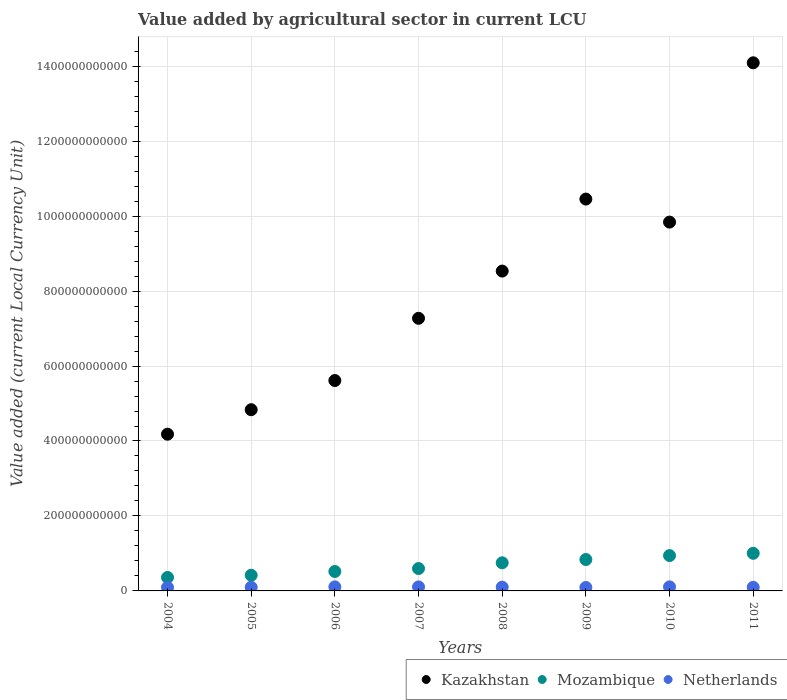How many different coloured dotlines are there?
Offer a terse response. 3. What is the value added by agricultural sector in Kazakhstan in 2006?
Offer a very short reply. 5.61e+11. Across all years, what is the maximum value added by agricultural sector in Mozambique?
Make the answer very short. 1.00e+11. Across all years, what is the minimum value added by agricultural sector in Kazakhstan?
Make the answer very short. 4.18e+11. What is the total value added by agricultural sector in Kazakhstan in the graph?
Offer a very short reply. 6.48e+12. What is the difference between the value added by agricultural sector in Mozambique in 2008 and that in 2011?
Offer a very short reply. -2.54e+1. What is the difference between the value added by agricultural sector in Kazakhstan in 2004 and the value added by agricultural sector in Netherlands in 2009?
Offer a very short reply. 4.09e+11. What is the average value added by agricultural sector in Netherlands per year?
Give a very brief answer. 1.01e+1. In the year 2010, what is the difference between the value added by agricultural sector in Mozambique and value added by agricultural sector in Netherlands?
Keep it short and to the point. 8.35e+1. In how many years, is the value added by agricultural sector in Netherlands greater than 280000000000 LCU?
Ensure brevity in your answer.  0. What is the ratio of the value added by agricultural sector in Netherlands in 2004 to that in 2009?
Make the answer very short. 1.03. Is the difference between the value added by agricultural sector in Mozambique in 2004 and 2011 greater than the difference between the value added by agricultural sector in Netherlands in 2004 and 2011?
Provide a succinct answer. No. What is the difference between the highest and the second highest value added by agricultural sector in Kazakhstan?
Your answer should be very brief. 3.64e+11. What is the difference between the highest and the lowest value added by agricultural sector in Netherlands?
Provide a succinct answer. 1.71e+09. Is the sum of the value added by agricultural sector in Netherlands in 2007 and 2011 greater than the maximum value added by agricultural sector in Mozambique across all years?
Give a very brief answer. No. Is it the case that in every year, the sum of the value added by agricultural sector in Mozambique and value added by agricultural sector in Kazakhstan  is greater than the value added by agricultural sector in Netherlands?
Offer a very short reply. Yes. Does the value added by agricultural sector in Mozambique monotonically increase over the years?
Offer a very short reply. Yes. Is the value added by agricultural sector in Kazakhstan strictly greater than the value added by agricultural sector in Netherlands over the years?
Give a very brief answer. Yes. What is the difference between two consecutive major ticks on the Y-axis?
Ensure brevity in your answer.  2.00e+11. Are the values on the major ticks of Y-axis written in scientific E-notation?
Your response must be concise. No. Does the graph contain grids?
Keep it short and to the point. Yes. Where does the legend appear in the graph?
Your response must be concise. Bottom right. What is the title of the graph?
Give a very brief answer. Value added by agricultural sector in current LCU. Does "Honduras" appear as one of the legend labels in the graph?
Provide a succinct answer. No. What is the label or title of the X-axis?
Make the answer very short. Years. What is the label or title of the Y-axis?
Offer a terse response. Value added (current Local Currency Unit). What is the Value added (current Local Currency Unit) in Kazakhstan in 2004?
Offer a terse response. 4.18e+11. What is the Value added (current Local Currency Unit) of Mozambique in 2004?
Make the answer very short. 3.59e+1. What is the Value added (current Local Currency Unit) of Netherlands in 2004?
Your response must be concise. 9.42e+09. What is the Value added (current Local Currency Unit) in Kazakhstan in 2005?
Your answer should be compact. 4.83e+11. What is the Value added (current Local Currency Unit) of Mozambique in 2005?
Your response must be concise. 4.18e+1. What is the Value added (current Local Currency Unit) in Netherlands in 2005?
Your answer should be compact. 9.77e+09. What is the Value added (current Local Currency Unit) of Kazakhstan in 2006?
Your response must be concise. 5.61e+11. What is the Value added (current Local Currency Unit) in Mozambique in 2006?
Keep it short and to the point. 5.19e+1. What is the Value added (current Local Currency Unit) in Netherlands in 2006?
Offer a very short reply. 1.09e+1. What is the Value added (current Local Currency Unit) in Kazakhstan in 2007?
Your answer should be very brief. 7.27e+11. What is the Value added (current Local Currency Unit) of Mozambique in 2007?
Offer a terse response. 5.97e+1. What is the Value added (current Local Currency Unit) of Netherlands in 2007?
Offer a very short reply. 1.08e+1. What is the Value added (current Local Currency Unit) in Kazakhstan in 2008?
Keep it short and to the point. 8.53e+11. What is the Value added (current Local Currency Unit) in Mozambique in 2008?
Provide a succinct answer. 7.50e+1. What is the Value added (current Local Currency Unit) in Netherlands in 2008?
Your answer should be very brief. 1.01e+1. What is the Value added (current Local Currency Unit) in Kazakhstan in 2009?
Offer a terse response. 1.05e+12. What is the Value added (current Local Currency Unit) of Mozambique in 2009?
Your answer should be very brief. 8.38e+1. What is the Value added (current Local Currency Unit) of Netherlands in 2009?
Keep it short and to the point. 9.19e+09. What is the Value added (current Local Currency Unit) of Kazakhstan in 2010?
Make the answer very short. 9.84e+11. What is the Value added (current Local Currency Unit) of Mozambique in 2010?
Your answer should be compact. 9.43e+1. What is the Value added (current Local Currency Unit) of Netherlands in 2010?
Make the answer very short. 1.08e+1. What is the Value added (current Local Currency Unit) in Kazakhstan in 2011?
Provide a short and direct response. 1.41e+12. What is the Value added (current Local Currency Unit) of Mozambique in 2011?
Ensure brevity in your answer.  1.00e+11. What is the Value added (current Local Currency Unit) of Netherlands in 2011?
Your response must be concise. 9.70e+09. Across all years, what is the maximum Value added (current Local Currency Unit) in Kazakhstan?
Make the answer very short. 1.41e+12. Across all years, what is the maximum Value added (current Local Currency Unit) in Mozambique?
Your answer should be compact. 1.00e+11. Across all years, what is the maximum Value added (current Local Currency Unit) in Netherlands?
Provide a succinct answer. 1.09e+1. Across all years, what is the minimum Value added (current Local Currency Unit) in Kazakhstan?
Your answer should be very brief. 4.18e+11. Across all years, what is the minimum Value added (current Local Currency Unit) in Mozambique?
Provide a succinct answer. 3.59e+1. Across all years, what is the minimum Value added (current Local Currency Unit) of Netherlands?
Ensure brevity in your answer.  9.19e+09. What is the total Value added (current Local Currency Unit) in Kazakhstan in the graph?
Keep it short and to the point. 6.48e+12. What is the total Value added (current Local Currency Unit) of Mozambique in the graph?
Provide a succinct answer. 5.43e+11. What is the total Value added (current Local Currency Unit) in Netherlands in the graph?
Your response must be concise. 8.07e+1. What is the difference between the Value added (current Local Currency Unit) of Kazakhstan in 2004 and that in 2005?
Your answer should be compact. -6.54e+1. What is the difference between the Value added (current Local Currency Unit) in Mozambique in 2004 and that in 2005?
Make the answer very short. -5.84e+09. What is the difference between the Value added (current Local Currency Unit) of Netherlands in 2004 and that in 2005?
Ensure brevity in your answer.  -3.41e+08. What is the difference between the Value added (current Local Currency Unit) of Kazakhstan in 2004 and that in 2006?
Offer a terse response. -1.43e+11. What is the difference between the Value added (current Local Currency Unit) in Mozambique in 2004 and that in 2006?
Ensure brevity in your answer.  -1.59e+1. What is the difference between the Value added (current Local Currency Unit) of Netherlands in 2004 and that in 2006?
Your response must be concise. -1.48e+09. What is the difference between the Value added (current Local Currency Unit) of Kazakhstan in 2004 and that in 2007?
Give a very brief answer. -3.09e+11. What is the difference between the Value added (current Local Currency Unit) of Mozambique in 2004 and that in 2007?
Ensure brevity in your answer.  -2.38e+1. What is the difference between the Value added (current Local Currency Unit) of Netherlands in 2004 and that in 2007?
Your answer should be very brief. -1.34e+09. What is the difference between the Value added (current Local Currency Unit) of Kazakhstan in 2004 and that in 2008?
Provide a short and direct response. -4.35e+11. What is the difference between the Value added (current Local Currency Unit) in Mozambique in 2004 and that in 2008?
Keep it short and to the point. -3.91e+1. What is the difference between the Value added (current Local Currency Unit) in Netherlands in 2004 and that in 2008?
Provide a succinct answer. -6.74e+08. What is the difference between the Value added (current Local Currency Unit) in Kazakhstan in 2004 and that in 2009?
Provide a succinct answer. -6.27e+11. What is the difference between the Value added (current Local Currency Unit) of Mozambique in 2004 and that in 2009?
Your answer should be compact. -4.78e+1. What is the difference between the Value added (current Local Currency Unit) in Netherlands in 2004 and that in 2009?
Provide a short and direct response. 2.33e+08. What is the difference between the Value added (current Local Currency Unit) of Kazakhstan in 2004 and that in 2010?
Keep it short and to the point. -5.66e+11. What is the difference between the Value added (current Local Currency Unit) of Mozambique in 2004 and that in 2010?
Keep it short and to the point. -5.84e+1. What is the difference between the Value added (current Local Currency Unit) in Netherlands in 2004 and that in 2010?
Offer a very short reply. -1.40e+09. What is the difference between the Value added (current Local Currency Unit) in Kazakhstan in 2004 and that in 2011?
Give a very brief answer. -9.91e+11. What is the difference between the Value added (current Local Currency Unit) of Mozambique in 2004 and that in 2011?
Your answer should be compact. -6.44e+1. What is the difference between the Value added (current Local Currency Unit) of Netherlands in 2004 and that in 2011?
Provide a succinct answer. -2.72e+08. What is the difference between the Value added (current Local Currency Unit) of Kazakhstan in 2005 and that in 2006?
Make the answer very short. -7.78e+1. What is the difference between the Value added (current Local Currency Unit) of Mozambique in 2005 and that in 2006?
Your answer should be very brief. -1.01e+1. What is the difference between the Value added (current Local Currency Unit) of Netherlands in 2005 and that in 2006?
Offer a terse response. -1.14e+09. What is the difference between the Value added (current Local Currency Unit) in Kazakhstan in 2005 and that in 2007?
Keep it short and to the point. -2.44e+11. What is the difference between the Value added (current Local Currency Unit) of Mozambique in 2005 and that in 2007?
Provide a short and direct response. -1.79e+1. What is the difference between the Value added (current Local Currency Unit) of Netherlands in 2005 and that in 2007?
Keep it short and to the point. -9.94e+08. What is the difference between the Value added (current Local Currency Unit) of Kazakhstan in 2005 and that in 2008?
Your response must be concise. -3.70e+11. What is the difference between the Value added (current Local Currency Unit) of Mozambique in 2005 and that in 2008?
Your answer should be very brief. -3.32e+1. What is the difference between the Value added (current Local Currency Unit) in Netherlands in 2005 and that in 2008?
Offer a terse response. -3.33e+08. What is the difference between the Value added (current Local Currency Unit) of Kazakhstan in 2005 and that in 2009?
Your response must be concise. -5.62e+11. What is the difference between the Value added (current Local Currency Unit) of Mozambique in 2005 and that in 2009?
Offer a very short reply. -4.20e+1. What is the difference between the Value added (current Local Currency Unit) in Netherlands in 2005 and that in 2009?
Give a very brief answer. 5.74e+08. What is the difference between the Value added (current Local Currency Unit) in Kazakhstan in 2005 and that in 2010?
Your answer should be compact. -5.01e+11. What is the difference between the Value added (current Local Currency Unit) in Mozambique in 2005 and that in 2010?
Your answer should be compact. -5.25e+1. What is the difference between the Value added (current Local Currency Unit) in Netherlands in 2005 and that in 2010?
Offer a very short reply. -1.06e+09. What is the difference between the Value added (current Local Currency Unit) of Kazakhstan in 2005 and that in 2011?
Offer a very short reply. -9.26e+11. What is the difference between the Value added (current Local Currency Unit) of Mozambique in 2005 and that in 2011?
Provide a succinct answer. -5.86e+1. What is the difference between the Value added (current Local Currency Unit) of Netherlands in 2005 and that in 2011?
Offer a very short reply. 6.90e+07. What is the difference between the Value added (current Local Currency Unit) in Kazakhstan in 2006 and that in 2007?
Your response must be concise. -1.66e+11. What is the difference between the Value added (current Local Currency Unit) of Mozambique in 2006 and that in 2007?
Your answer should be compact. -7.85e+09. What is the difference between the Value added (current Local Currency Unit) of Netherlands in 2006 and that in 2007?
Provide a succinct answer. 1.42e+08. What is the difference between the Value added (current Local Currency Unit) in Kazakhstan in 2006 and that in 2008?
Your answer should be compact. -2.92e+11. What is the difference between the Value added (current Local Currency Unit) in Mozambique in 2006 and that in 2008?
Your response must be concise. -2.32e+1. What is the difference between the Value added (current Local Currency Unit) in Netherlands in 2006 and that in 2008?
Your answer should be compact. 8.03e+08. What is the difference between the Value added (current Local Currency Unit) of Kazakhstan in 2006 and that in 2009?
Offer a very short reply. -4.84e+11. What is the difference between the Value added (current Local Currency Unit) in Mozambique in 2006 and that in 2009?
Offer a terse response. -3.19e+1. What is the difference between the Value added (current Local Currency Unit) in Netherlands in 2006 and that in 2009?
Your answer should be very brief. 1.71e+09. What is the difference between the Value added (current Local Currency Unit) of Kazakhstan in 2006 and that in 2010?
Your answer should be compact. -4.23e+11. What is the difference between the Value added (current Local Currency Unit) of Mozambique in 2006 and that in 2010?
Provide a succinct answer. -4.24e+1. What is the difference between the Value added (current Local Currency Unit) in Netherlands in 2006 and that in 2010?
Ensure brevity in your answer.  7.40e+07. What is the difference between the Value added (current Local Currency Unit) of Kazakhstan in 2006 and that in 2011?
Your answer should be compact. -8.48e+11. What is the difference between the Value added (current Local Currency Unit) in Mozambique in 2006 and that in 2011?
Keep it short and to the point. -4.85e+1. What is the difference between the Value added (current Local Currency Unit) of Netherlands in 2006 and that in 2011?
Your answer should be compact. 1.20e+09. What is the difference between the Value added (current Local Currency Unit) in Kazakhstan in 2007 and that in 2008?
Offer a very short reply. -1.26e+11. What is the difference between the Value added (current Local Currency Unit) of Mozambique in 2007 and that in 2008?
Ensure brevity in your answer.  -1.53e+1. What is the difference between the Value added (current Local Currency Unit) in Netherlands in 2007 and that in 2008?
Your answer should be very brief. 6.61e+08. What is the difference between the Value added (current Local Currency Unit) in Kazakhstan in 2007 and that in 2009?
Your answer should be very brief. -3.18e+11. What is the difference between the Value added (current Local Currency Unit) of Mozambique in 2007 and that in 2009?
Ensure brevity in your answer.  -2.41e+1. What is the difference between the Value added (current Local Currency Unit) of Netherlands in 2007 and that in 2009?
Offer a terse response. 1.57e+09. What is the difference between the Value added (current Local Currency Unit) of Kazakhstan in 2007 and that in 2010?
Give a very brief answer. -2.57e+11. What is the difference between the Value added (current Local Currency Unit) in Mozambique in 2007 and that in 2010?
Your answer should be compact. -3.46e+1. What is the difference between the Value added (current Local Currency Unit) of Netherlands in 2007 and that in 2010?
Your response must be concise. -6.80e+07. What is the difference between the Value added (current Local Currency Unit) of Kazakhstan in 2007 and that in 2011?
Provide a succinct answer. -6.82e+11. What is the difference between the Value added (current Local Currency Unit) in Mozambique in 2007 and that in 2011?
Give a very brief answer. -4.07e+1. What is the difference between the Value added (current Local Currency Unit) of Netherlands in 2007 and that in 2011?
Make the answer very short. 1.06e+09. What is the difference between the Value added (current Local Currency Unit) of Kazakhstan in 2008 and that in 2009?
Offer a very short reply. -1.92e+11. What is the difference between the Value added (current Local Currency Unit) in Mozambique in 2008 and that in 2009?
Your answer should be very brief. -8.76e+09. What is the difference between the Value added (current Local Currency Unit) in Netherlands in 2008 and that in 2009?
Make the answer very short. 9.07e+08. What is the difference between the Value added (current Local Currency Unit) of Kazakhstan in 2008 and that in 2010?
Your answer should be compact. -1.31e+11. What is the difference between the Value added (current Local Currency Unit) in Mozambique in 2008 and that in 2010?
Offer a terse response. -1.93e+1. What is the difference between the Value added (current Local Currency Unit) of Netherlands in 2008 and that in 2010?
Provide a short and direct response. -7.29e+08. What is the difference between the Value added (current Local Currency Unit) of Kazakhstan in 2008 and that in 2011?
Your answer should be very brief. -5.56e+11. What is the difference between the Value added (current Local Currency Unit) in Mozambique in 2008 and that in 2011?
Ensure brevity in your answer.  -2.54e+1. What is the difference between the Value added (current Local Currency Unit) in Netherlands in 2008 and that in 2011?
Provide a short and direct response. 4.02e+08. What is the difference between the Value added (current Local Currency Unit) of Kazakhstan in 2009 and that in 2010?
Provide a short and direct response. 6.14e+1. What is the difference between the Value added (current Local Currency Unit) of Mozambique in 2009 and that in 2010?
Keep it short and to the point. -1.05e+1. What is the difference between the Value added (current Local Currency Unit) of Netherlands in 2009 and that in 2010?
Provide a short and direct response. -1.64e+09. What is the difference between the Value added (current Local Currency Unit) of Kazakhstan in 2009 and that in 2011?
Ensure brevity in your answer.  -3.64e+11. What is the difference between the Value added (current Local Currency Unit) in Mozambique in 2009 and that in 2011?
Provide a short and direct response. -1.66e+1. What is the difference between the Value added (current Local Currency Unit) in Netherlands in 2009 and that in 2011?
Your response must be concise. -5.05e+08. What is the difference between the Value added (current Local Currency Unit) of Kazakhstan in 2010 and that in 2011?
Make the answer very short. -4.25e+11. What is the difference between the Value added (current Local Currency Unit) of Mozambique in 2010 and that in 2011?
Ensure brevity in your answer.  -6.08e+09. What is the difference between the Value added (current Local Currency Unit) of Netherlands in 2010 and that in 2011?
Make the answer very short. 1.13e+09. What is the difference between the Value added (current Local Currency Unit) in Kazakhstan in 2004 and the Value added (current Local Currency Unit) in Mozambique in 2005?
Your answer should be very brief. 3.76e+11. What is the difference between the Value added (current Local Currency Unit) of Kazakhstan in 2004 and the Value added (current Local Currency Unit) of Netherlands in 2005?
Make the answer very short. 4.08e+11. What is the difference between the Value added (current Local Currency Unit) in Mozambique in 2004 and the Value added (current Local Currency Unit) in Netherlands in 2005?
Ensure brevity in your answer.  2.62e+1. What is the difference between the Value added (current Local Currency Unit) of Kazakhstan in 2004 and the Value added (current Local Currency Unit) of Mozambique in 2006?
Your answer should be compact. 3.66e+11. What is the difference between the Value added (current Local Currency Unit) in Kazakhstan in 2004 and the Value added (current Local Currency Unit) in Netherlands in 2006?
Your answer should be compact. 4.07e+11. What is the difference between the Value added (current Local Currency Unit) in Mozambique in 2004 and the Value added (current Local Currency Unit) in Netherlands in 2006?
Offer a terse response. 2.50e+1. What is the difference between the Value added (current Local Currency Unit) of Kazakhstan in 2004 and the Value added (current Local Currency Unit) of Mozambique in 2007?
Give a very brief answer. 3.58e+11. What is the difference between the Value added (current Local Currency Unit) in Kazakhstan in 2004 and the Value added (current Local Currency Unit) in Netherlands in 2007?
Keep it short and to the point. 4.07e+11. What is the difference between the Value added (current Local Currency Unit) of Mozambique in 2004 and the Value added (current Local Currency Unit) of Netherlands in 2007?
Offer a very short reply. 2.52e+1. What is the difference between the Value added (current Local Currency Unit) of Kazakhstan in 2004 and the Value added (current Local Currency Unit) of Mozambique in 2008?
Your answer should be very brief. 3.43e+11. What is the difference between the Value added (current Local Currency Unit) in Kazakhstan in 2004 and the Value added (current Local Currency Unit) in Netherlands in 2008?
Offer a very short reply. 4.08e+11. What is the difference between the Value added (current Local Currency Unit) of Mozambique in 2004 and the Value added (current Local Currency Unit) of Netherlands in 2008?
Offer a very short reply. 2.58e+1. What is the difference between the Value added (current Local Currency Unit) in Kazakhstan in 2004 and the Value added (current Local Currency Unit) in Mozambique in 2009?
Give a very brief answer. 3.34e+11. What is the difference between the Value added (current Local Currency Unit) in Kazakhstan in 2004 and the Value added (current Local Currency Unit) in Netherlands in 2009?
Offer a terse response. 4.09e+11. What is the difference between the Value added (current Local Currency Unit) in Mozambique in 2004 and the Value added (current Local Currency Unit) in Netherlands in 2009?
Ensure brevity in your answer.  2.67e+1. What is the difference between the Value added (current Local Currency Unit) of Kazakhstan in 2004 and the Value added (current Local Currency Unit) of Mozambique in 2010?
Provide a succinct answer. 3.24e+11. What is the difference between the Value added (current Local Currency Unit) of Kazakhstan in 2004 and the Value added (current Local Currency Unit) of Netherlands in 2010?
Provide a short and direct response. 4.07e+11. What is the difference between the Value added (current Local Currency Unit) of Mozambique in 2004 and the Value added (current Local Currency Unit) of Netherlands in 2010?
Offer a very short reply. 2.51e+1. What is the difference between the Value added (current Local Currency Unit) in Kazakhstan in 2004 and the Value added (current Local Currency Unit) in Mozambique in 2011?
Your answer should be very brief. 3.18e+11. What is the difference between the Value added (current Local Currency Unit) in Kazakhstan in 2004 and the Value added (current Local Currency Unit) in Netherlands in 2011?
Offer a terse response. 4.08e+11. What is the difference between the Value added (current Local Currency Unit) in Mozambique in 2004 and the Value added (current Local Currency Unit) in Netherlands in 2011?
Your answer should be compact. 2.62e+1. What is the difference between the Value added (current Local Currency Unit) in Kazakhstan in 2005 and the Value added (current Local Currency Unit) in Mozambique in 2006?
Your response must be concise. 4.32e+11. What is the difference between the Value added (current Local Currency Unit) of Kazakhstan in 2005 and the Value added (current Local Currency Unit) of Netherlands in 2006?
Provide a succinct answer. 4.73e+11. What is the difference between the Value added (current Local Currency Unit) of Mozambique in 2005 and the Value added (current Local Currency Unit) of Netherlands in 2006?
Ensure brevity in your answer.  3.09e+1. What is the difference between the Value added (current Local Currency Unit) in Kazakhstan in 2005 and the Value added (current Local Currency Unit) in Mozambique in 2007?
Give a very brief answer. 4.24e+11. What is the difference between the Value added (current Local Currency Unit) of Kazakhstan in 2005 and the Value added (current Local Currency Unit) of Netherlands in 2007?
Your response must be concise. 4.73e+11. What is the difference between the Value added (current Local Currency Unit) in Mozambique in 2005 and the Value added (current Local Currency Unit) in Netherlands in 2007?
Keep it short and to the point. 3.10e+1. What is the difference between the Value added (current Local Currency Unit) of Kazakhstan in 2005 and the Value added (current Local Currency Unit) of Mozambique in 2008?
Keep it short and to the point. 4.08e+11. What is the difference between the Value added (current Local Currency Unit) of Kazakhstan in 2005 and the Value added (current Local Currency Unit) of Netherlands in 2008?
Ensure brevity in your answer.  4.73e+11. What is the difference between the Value added (current Local Currency Unit) of Mozambique in 2005 and the Value added (current Local Currency Unit) of Netherlands in 2008?
Your answer should be compact. 3.17e+1. What is the difference between the Value added (current Local Currency Unit) of Kazakhstan in 2005 and the Value added (current Local Currency Unit) of Mozambique in 2009?
Provide a succinct answer. 4.00e+11. What is the difference between the Value added (current Local Currency Unit) in Kazakhstan in 2005 and the Value added (current Local Currency Unit) in Netherlands in 2009?
Keep it short and to the point. 4.74e+11. What is the difference between the Value added (current Local Currency Unit) in Mozambique in 2005 and the Value added (current Local Currency Unit) in Netherlands in 2009?
Offer a very short reply. 3.26e+1. What is the difference between the Value added (current Local Currency Unit) in Kazakhstan in 2005 and the Value added (current Local Currency Unit) in Mozambique in 2010?
Give a very brief answer. 3.89e+11. What is the difference between the Value added (current Local Currency Unit) in Kazakhstan in 2005 and the Value added (current Local Currency Unit) in Netherlands in 2010?
Offer a terse response. 4.73e+11. What is the difference between the Value added (current Local Currency Unit) in Mozambique in 2005 and the Value added (current Local Currency Unit) in Netherlands in 2010?
Give a very brief answer. 3.10e+1. What is the difference between the Value added (current Local Currency Unit) in Kazakhstan in 2005 and the Value added (current Local Currency Unit) in Mozambique in 2011?
Offer a terse response. 3.83e+11. What is the difference between the Value added (current Local Currency Unit) of Kazakhstan in 2005 and the Value added (current Local Currency Unit) of Netherlands in 2011?
Keep it short and to the point. 4.74e+11. What is the difference between the Value added (current Local Currency Unit) of Mozambique in 2005 and the Value added (current Local Currency Unit) of Netherlands in 2011?
Provide a short and direct response. 3.21e+1. What is the difference between the Value added (current Local Currency Unit) of Kazakhstan in 2006 and the Value added (current Local Currency Unit) of Mozambique in 2007?
Give a very brief answer. 5.02e+11. What is the difference between the Value added (current Local Currency Unit) in Kazakhstan in 2006 and the Value added (current Local Currency Unit) in Netherlands in 2007?
Provide a succinct answer. 5.51e+11. What is the difference between the Value added (current Local Currency Unit) in Mozambique in 2006 and the Value added (current Local Currency Unit) in Netherlands in 2007?
Your answer should be compact. 4.11e+1. What is the difference between the Value added (current Local Currency Unit) of Kazakhstan in 2006 and the Value added (current Local Currency Unit) of Mozambique in 2008?
Your response must be concise. 4.86e+11. What is the difference between the Value added (current Local Currency Unit) in Kazakhstan in 2006 and the Value added (current Local Currency Unit) in Netherlands in 2008?
Offer a terse response. 5.51e+11. What is the difference between the Value added (current Local Currency Unit) of Mozambique in 2006 and the Value added (current Local Currency Unit) of Netherlands in 2008?
Your answer should be compact. 4.18e+1. What is the difference between the Value added (current Local Currency Unit) in Kazakhstan in 2006 and the Value added (current Local Currency Unit) in Mozambique in 2009?
Keep it short and to the point. 4.78e+11. What is the difference between the Value added (current Local Currency Unit) in Kazakhstan in 2006 and the Value added (current Local Currency Unit) in Netherlands in 2009?
Your answer should be very brief. 5.52e+11. What is the difference between the Value added (current Local Currency Unit) in Mozambique in 2006 and the Value added (current Local Currency Unit) in Netherlands in 2009?
Provide a succinct answer. 4.27e+1. What is the difference between the Value added (current Local Currency Unit) in Kazakhstan in 2006 and the Value added (current Local Currency Unit) in Mozambique in 2010?
Give a very brief answer. 4.67e+11. What is the difference between the Value added (current Local Currency Unit) in Kazakhstan in 2006 and the Value added (current Local Currency Unit) in Netherlands in 2010?
Provide a succinct answer. 5.51e+11. What is the difference between the Value added (current Local Currency Unit) of Mozambique in 2006 and the Value added (current Local Currency Unit) of Netherlands in 2010?
Make the answer very short. 4.10e+1. What is the difference between the Value added (current Local Currency Unit) of Kazakhstan in 2006 and the Value added (current Local Currency Unit) of Mozambique in 2011?
Offer a very short reply. 4.61e+11. What is the difference between the Value added (current Local Currency Unit) of Kazakhstan in 2006 and the Value added (current Local Currency Unit) of Netherlands in 2011?
Your answer should be compact. 5.52e+11. What is the difference between the Value added (current Local Currency Unit) in Mozambique in 2006 and the Value added (current Local Currency Unit) in Netherlands in 2011?
Give a very brief answer. 4.22e+1. What is the difference between the Value added (current Local Currency Unit) of Kazakhstan in 2007 and the Value added (current Local Currency Unit) of Mozambique in 2008?
Give a very brief answer. 6.52e+11. What is the difference between the Value added (current Local Currency Unit) of Kazakhstan in 2007 and the Value added (current Local Currency Unit) of Netherlands in 2008?
Make the answer very short. 7.17e+11. What is the difference between the Value added (current Local Currency Unit) of Mozambique in 2007 and the Value added (current Local Currency Unit) of Netherlands in 2008?
Your response must be concise. 4.96e+1. What is the difference between the Value added (current Local Currency Unit) of Kazakhstan in 2007 and the Value added (current Local Currency Unit) of Mozambique in 2009?
Keep it short and to the point. 6.44e+11. What is the difference between the Value added (current Local Currency Unit) of Kazakhstan in 2007 and the Value added (current Local Currency Unit) of Netherlands in 2009?
Give a very brief answer. 7.18e+11. What is the difference between the Value added (current Local Currency Unit) of Mozambique in 2007 and the Value added (current Local Currency Unit) of Netherlands in 2009?
Ensure brevity in your answer.  5.05e+1. What is the difference between the Value added (current Local Currency Unit) of Kazakhstan in 2007 and the Value added (current Local Currency Unit) of Mozambique in 2010?
Make the answer very short. 6.33e+11. What is the difference between the Value added (current Local Currency Unit) in Kazakhstan in 2007 and the Value added (current Local Currency Unit) in Netherlands in 2010?
Your answer should be compact. 7.17e+11. What is the difference between the Value added (current Local Currency Unit) of Mozambique in 2007 and the Value added (current Local Currency Unit) of Netherlands in 2010?
Offer a very short reply. 4.89e+1. What is the difference between the Value added (current Local Currency Unit) of Kazakhstan in 2007 and the Value added (current Local Currency Unit) of Mozambique in 2011?
Offer a very short reply. 6.27e+11. What is the difference between the Value added (current Local Currency Unit) of Kazakhstan in 2007 and the Value added (current Local Currency Unit) of Netherlands in 2011?
Your answer should be very brief. 7.18e+11. What is the difference between the Value added (current Local Currency Unit) of Mozambique in 2007 and the Value added (current Local Currency Unit) of Netherlands in 2011?
Your answer should be compact. 5.00e+1. What is the difference between the Value added (current Local Currency Unit) of Kazakhstan in 2008 and the Value added (current Local Currency Unit) of Mozambique in 2009?
Your answer should be compact. 7.70e+11. What is the difference between the Value added (current Local Currency Unit) in Kazakhstan in 2008 and the Value added (current Local Currency Unit) in Netherlands in 2009?
Your answer should be compact. 8.44e+11. What is the difference between the Value added (current Local Currency Unit) in Mozambique in 2008 and the Value added (current Local Currency Unit) in Netherlands in 2009?
Make the answer very short. 6.58e+1. What is the difference between the Value added (current Local Currency Unit) of Kazakhstan in 2008 and the Value added (current Local Currency Unit) of Mozambique in 2010?
Ensure brevity in your answer.  7.59e+11. What is the difference between the Value added (current Local Currency Unit) of Kazakhstan in 2008 and the Value added (current Local Currency Unit) of Netherlands in 2010?
Your answer should be compact. 8.43e+11. What is the difference between the Value added (current Local Currency Unit) in Mozambique in 2008 and the Value added (current Local Currency Unit) in Netherlands in 2010?
Your response must be concise. 6.42e+1. What is the difference between the Value added (current Local Currency Unit) of Kazakhstan in 2008 and the Value added (current Local Currency Unit) of Mozambique in 2011?
Provide a short and direct response. 7.53e+11. What is the difference between the Value added (current Local Currency Unit) of Kazakhstan in 2008 and the Value added (current Local Currency Unit) of Netherlands in 2011?
Offer a terse response. 8.44e+11. What is the difference between the Value added (current Local Currency Unit) of Mozambique in 2008 and the Value added (current Local Currency Unit) of Netherlands in 2011?
Provide a succinct answer. 6.53e+1. What is the difference between the Value added (current Local Currency Unit) of Kazakhstan in 2009 and the Value added (current Local Currency Unit) of Mozambique in 2010?
Provide a short and direct response. 9.51e+11. What is the difference between the Value added (current Local Currency Unit) in Kazakhstan in 2009 and the Value added (current Local Currency Unit) in Netherlands in 2010?
Offer a very short reply. 1.03e+12. What is the difference between the Value added (current Local Currency Unit) of Mozambique in 2009 and the Value added (current Local Currency Unit) of Netherlands in 2010?
Ensure brevity in your answer.  7.30e+1. What is the difference between the Value added (current Local Currency Unit) in Kazakhstan in 2009 and the Value added (current Local Currency Unit) in Mozambique in 2011?
Offer a very short reply. 9.45e+11. What is the difference between the Value added (current Local Currency Unit) in Kazakhstan in 2009 and the Value added (current Local Currency Unit) in Netherlands in 2011?
Make the answer very short. 1.04e+12. What is the difference between the Value added (current Local Currency Unit) in Mozambique in 2009 and the Value added (current Local Currency Unit) in Netherlands in 2011?
Make the answer very short. 7.41e+1. What is the difference between the Value added (current Local Currency Unit) in Kazakhstan in 2010 and the Value added (current Local Currency Unit) in Mozambique in 2011?
Ensure brevity in your answer.  8.84e+11. What is the difference between the Value added (current Local Currency Unit) in Kazakhstan in 2010 and the Value added (current Local Currency Unit) in Netherlands in 2011?
Keep it short and to the point. 9.74e+11. What is the difference between the Value added (current Local Currency Unit) of Mozambique in 2010 and the Value added (current Local Currency Unit) of Netherlands in 2011?
Make the answer very short. 8.46e+1. What is the average Value added (current Local Currency Unit) in Kazakhstan per year?
Offer a terse response. 8.10e+11. What is the average Value added (current Local Currency Unit) in Mozambique per year?
Offer a terse response. 6.78e+1. What is the average Value added (current Local Currency Unit) in Netherlands per year?
Make the answer very short. 1.01e+1. In the year 2004, what is the difference between the Value added (current Local Currency Unit) in Kazakhstan and Value added (current Local Currency Unit) in Mozambique?
Your answer should be compact. 3.82e+11. In the year 2004, what is the difference between the Value added (current Local Currency Unit) in Kazakhstan and Value added (current Local Currency Unit) in Netherlands?
Your response must be concise. 4.09e+11. In the year 2004, what is the difference between the Value added (current Local Currency Unit) of Mozambique and Value added (current Local Currency Unit) of Netherlands?
Offer a very short reply. 2.65e+1. In the year 2005, what is the difference between the Value added (current Local Currency Unit) in Kazakhstan and Value added (current Local Currency Unit) in Mozambique?
Make the answer very short. 4.42e+11. In the year 2005, what is the difference between the Value added (current Local Currency Unit) of Kazakhstan and Value added (current Local Currency Unit) of Netherlands?
Offer a very short reply. 4.74e+11. In the year 2005, what is the difference between the Value added (current Local Currency Unit) in Mozambique and Value added (current Local Currency Unit) in Netherlands?
Give a very brief answer. 3.20e+1. In the year 2006, what is the difference between the Value added (current Local Currency Unit) in Kazakhstan and Value added (current Local Currency Unit) in Mozambique?
Offer a terse response. 5.09e+11. In the year 2006, what is the difference between the Value added (current Local Currency Unit) of Kazakhstan and Value added (current Local Currency Unit) of Netherlands?
Provide a succinct answer. 5.50e+11. In the year 2006, what is the difference between the Value added (current Local Currency Unit) of Mozambique and Value added (current Local Currency Unit) of Netherlands?
Offer a terse response. 4.10e+1. In the year 2007, what is the difference between the Value added (current Local Currency Unit) of Kazakhstan and Value added (current Local Currency Unit) of Mozambique?
Provide a succinct answer. 6.68e+11. In the year 2007, what is the difference between the Value added (current Local Currency Unit) in Kazakhstan and Value added (current Local Currency Unit) in Netherlands?
Offer a very short reply. 7.17e+11. In the year 2007, what is the difference between the Value added (current Local Currency Unit) of Mozambique and Value added (current Local Currency Unit) of Netherlands?
Give a very brief answer. 4.89e+1. In the year 2008, what is the difference between the Value added (current Local Currency Unit) in Kazakhstan and Value added (current Local Currency Unit) in Mozambique?
Give a very brief answer. 7.78e+11. In the year 2008, what is the difference between the Value added (current Local Currency Unit) in Kazakhstan and Value added (current Local Currency Unit) in Netherlands?
Provide a succinct answer. 8.43e+11. In the year 2008, what is the difference between the Value added (current Local Currency Unit) of Mozambique and Value added (current Local Currency Unit) of Netherlands?
Give a very brief answer. 6.49e+1. In the year 2009, what is the difference between the Value added (current Local Currency Unit) in Kazakhstan and Value added (current Local Currency Unit) in Mozambique?
Your answer should be very brief. 9.62e+11. In the year 2009, what is the difference between the Value added (current Local Currency Unit) of Kazakhstan and Value added (current Local Currency Unit) of Netherlands?
Offer a very short reply. 1.04e+12. In the year 2009, what is the difference between the Value added (current Local Currency Unit) in Mozambique and Value added (current Local Currency Unit) in Netherlands?
Your response must be concise. 7.46e+1. In the year 2010, what is the difference between the Value added (current Local Currency Unit) of Kazakhstan and Value added (current Local Currency Unit) of Mozambique?
Your answer should be very brief. 8.90e+11. In the year 2010, what is the difference between the Value added (current Local Currency Unit) in Kazakhstan and Value added (current Local Currency Unit) in Netherlands?
Keep it short and to the point. 9.73e+11. In the year 2010, what is the difference between the Value added (current Local Currency Unit) of Mozambique and Value added (current Local Currency Unit) of Netherlands?
Keep it short and to the point. 8.35e+1. In the year 2011, what is the difference between the Value added (current Local Currency Unit) in Kazakhstan and Value added (current Local Currency Unit) in Mozambique?
Ensure brevity in your answer.  1.31e+12. In the year 2011, what is the difference between the Value added (current Local Currency Unit) of Kazakhstan and Value added (current Local Currency Unit) of Netherlands?
Give a very brief answer. 1.40e+12. In the year 2011, what is the difference between the Value added (current Local Currency Unit) of Mozambique and Value added (current Local Currency Unit) of Netherlands?
Offer a very short reply. 9.07e+1. What is the ratio of the Value added (current Local Currency Unit) of Kazakhstan in 2004 to that in 2005?
Offer a terse response. 0.86. What is the ratio of the Value added (current Local Currency Unit) in Mozambique in 2004 to that in 2005?
Your response must be concise. 0.86. What is the ratio of the Value added (current Local Currency Unit) in Netherlands in 2004 to that in 2005?
Give a very brief answer. 0.97. What is the ratio of the Value added (current Local Currency Unit) of Kazakhstan in 2004 to that in 2006?
Provide a short and direct response. 0.74. What is the ratio of the Value added (current Local Currency Unit) in Mozambique in 2004 to that in 2006?
Your answer should be very brief. 0.69. What is the ratio of the Value added (current Local Currency Unit) of Netherlands in 2004 to that in 2006?
Offer a very short reply. 0.86. What is the ratio of the Value added (current Local Currency Unit) in Kazakhstan in 2004 to that in 2007?
Your answer should be very brief. 0.57. What is the ratio of the Value added (current Local Currency Unit) of Mozambique in 2004 to that in 2007?
Ensure brevity in your answer.  0.6. What is the ratio of the Value added (current Local Currency Unit) in Netherlands in 2004 to that in 2007?
Provide a succinct answer. 0.88. What is the ratio of the Value added (current Local Currency Unit) in Kazakhstan in 2004 to that in 2008?
Your answer should be very brief. 0.49. What is the ratio of the Value added (current Local Currency Unit) of Mozambique in 2004 to that in 2008?
Give a very brief answer. 0.48. What is the ratio of the Value added (current Local Currency Unit) of Netherlands in 2004 to that in 2008?
Offer a terse response. 0.93. What is the ratio of the Value added (current Local Currency Unit) of Mozambique in 2004 to that in 2009?
Give a very brief answer. 0.43. What is the ratio of the Value added (current Local Currency Unit) in Netherlands in 2004 to that in 2009?
Ensure brevity in your answer.  1.03. What is the ratio of the Value added (current Local Currency Unit) of Kazakhstan in 2004 to that in 2010?
Provide a short and direct response. 0.42. What is the ratio of the Value added (current Local Currency Unit) in Mozambique in 2004 to that in 2010?
Offer a very short reply. 0.38. What is the ratio of the Value added (current Local Currency Unit) in Netherlands in 2004 to that in 2010?
Ensure brevity in your answer.  0.87. What is the ratio of the Value added (current Local Currency Unit) of Kazakhstan in 2004 to that in 2011?
Provide a short and direct response. 0.3. What is the ratio of the Value added (current Local Currency Unit) in Mozambique in 2004 to that in 2011?
Offer a very short reply. 0.36. What is the ratio of the Value added (current Local Currency Unit) in Netherlands in 2004 to that in 2011?
Your answer should be very brief. 0.97. What is the ratio of the Value added (current Local Currency Unit) in Kazakhstan in 2005 to that in 2006?
Your answer should be compact. 0.86. What is the ratio of the Value added (current Local Currency Unit) in Mozambique in 2005 to that in 2006?
Offer a very short reply. 0.81. What is the ratio of the Value added (current Local Currency Unit) of Netherlands in 2005 to that in 2006?
Provide a succinct answer. 0.9. What is the ratio of the Value added (current Local Currency Unit) of Kazakhstan in 2005 to that in 2007?
Your answer should be compact. 0.66. What is the ratio of the Value added (current Local Currency Unit) in Mozambique in 2005 to that in 2007?
Give a very brief answer. 0.7. What is the ratio of the Value added (current Local Currency Unit) of Netherlands in 2005 to that in 2007?
Provide a succinct answer. 0.91. What is the ratio of the Value added (current Local Currency Unit) in Kazakhstan in 2005 to that in 2008?
Make the answer very short. 0.57. What is the ratio of the Value added (current Local Currency Unit) in Mozambique in 2005 to that in 2008?
Provide a short and direct response. 0.56. What is the ratio of the Value added (current Local Currency Unit) of Kazakhstan in 2005 to that in 2009?
Offer a very short reply. 0.46. What is the ratio of the Value added (current Local Currency Unit) of Mozambique in 2005 to that in 2009?
Give a very brief answer. 0.5. What is the ratio of the Value added (current Local Currency Unit) in Netherlands in 2005 to that in 2009?
Make the answer very short. 1.06. What is the ratio of the Value added (current Local Currency Unit) of Kazakhstan in 2005 to that in 2010?
Provide a succinct answer. 0.49. What is the ratio of the Value added (current Local Currency Unit) of Mozambique in 2005 to that in 2010?
Give a very brief answer. 0.44. What is the ratio of the Value added (current Local Currency Unit) of Netherlands in 2005 to that in 2010?
Your answer should be compact. 0.9. What is the ratio of the Value added (current Local Currency Unit) of Kazakhstan in 2005 to that in 2011?
Offer a very short reply. 0.34. What is the ratio of the Value added (current Local Currency Unit) of Mozambique in 2005 to that in 2011?
Provide a short and direct response. 0.42. What is the ratio of the Value added (current Local Currency Unit) of Netherlands in 2005 to that in 2011?
Make the answer very short. 1.01. What is the ratio of the Value added (current Local Currency Unit) of Kazakhstan in 2006 to that in 2007?
Provide a short and direct response. 0.77. What is the ratio of the Value added (current Local Currency Unit) of Mozambique in 2006 to that in 2007?
Give a very brief answer. 0.87. What is the ratio of the Value added (current Local Currency Unit) of Netherlands in 2006 to that in 2007?
Your answer should be compact. 1.01. What is the ratio of the Value added (current Local Currency Unit) in Kazakhstan in 2006 to that in 2008?
Give a very brief answer. 0.66. What is the ratio of the Value added (current Local Currency Unit) in Mozambique in 2006 to that in 2008?
Offer a terse response. 0.69. What is the ratio of the Value added (current Local Currency Unit) of Netherlands in 2006 to that in 2008?
Your answer should be compact. 1.08. What is the ratio of the Value added (current Local Currency Unit) in Kazakhstan in 2006 to that in 2009?
Make the answer very short. 0.54. What is the ratio of the Value added (current Local Currency Unit) in Mozambique in 2006 to that in 2009?
Offer a terse response. 0.62. What is the ratio of the Value added (current Local Currency Unit) of Netherlands in 2006 to that in 2009?
Offer a terse response. 1.19. What is the ratio of the Value added (current Local Currency Unit) of Kazakhstan in 2006 to that in 2010?
Your answer should be very brief. 0.57. What is the ratio of the Value added (current Local Currency Unit) of Mozambique in 2006 to that in 2010?
Give a very brief answer. 0.55. What is the ratio of the Value added (current Local Currency Unit) of Netherlands in 2006 to that in 2010?
Offer a terse response. 1.01. What is the ratio of the Value added (current Local Currency Unit) of Kazakhstan in 2006 to that in 2011?
Keep it short and to the point. 0.4. What is the ratio of the Value added (current Local Currency Unit) in Mozambique in 2006 to that in 2011?
Your answer should be very brief. 0.52. What is the ratio of the Value added (current Local Currency Unit) of Netherlands in 2006 to that in 2011?
Ensure brevity in your answer.  1.12. What is the ratio of the Value added (current Local Currency Unit) of Kazakhstan in 2007 to that in 2008?
Give a very brief answer. 0.85. What is the ratio of the Value added (current Local Currency Unit) of Mozambique in 2007 to that in 2008?
Ensure brevity in your answer.  0.8. What is the ratio of the Value added (current Local Currency Unit) of Netherlands in 2007 to that in 2008?
Offer a terse response. 1.07. What is the ratio of the Value added (current Local Currency Unit) of Kazakhstan in 2007 to that in 2009?
Provide a succinct answer. 0.7. What is the ratio of the Value added (current Local Currency Unit) in Mozambique in 2007 to that in 2009?
Make the answer very short. 0.71. What is the ratio of the Value added (current Local Currency Unit) of Netherlands in 2007 to that in 2009?
Provide a short and direct response. 1.17. What is the ratio of the Value added (current Local Currency Unit) of Kazakhstan in 2007 to that in 2010?
Offer a terse response. 0.74. What is the ratio of the Value added (current Local Currency Unit) of Mozambique in 2007 to that in 2010?
Your response must be concise. 0.63. What is the ratio of the Value added (current Local Currency Unit) in Netherlands in 2007 to that in 2010?
Ensure brevity in your answer.  0.99. What is the ratio of the Value added (current Local Currency Unit) of Kazakhstan in 2007 to that in 2011?
Ensure brevity in your answer.  0.52. What is the ratio of the Value added (current Local Currency Unit) in Mozambique in 2007 to that in 2011?
Your answer should be very brief. 0.59. What is the ratio of the Value added (current Local Currency Unit) in Netherlands in 2007 to that in 2011?
Keep it short and to the point. 1.11. What is the ratio of the Value added (current Local Currency Unit) in Kazakhstan in 2008 to that in 2009?
Ensure brevity in your answer.  0.82. What is the ratio of the Value added (current Local Currency Unit) in Mozambique in 2008 to that in 2009?
Your answer should be compact. 0.9. What is the ratio of the Value added (current Local Currency Unit) in Netherlands in 2008 to that in 2009?
Provide a short and direct response. 1.1. What is the ratio of the Value added (current Local Currency Unit) of Kazakhstan in 2008 to that in 2010?
Offer a terse response. 0.87. What is the ratio of the Value added (current Local Currency Unit) in Mozambique in 2008 to that in 2010?
Keep it short and to the point. 0.8. What is the ratio of the Value added (current Local Currency Unit) of Netherlands in 2008 to that in 2010?
Keep it short and to the point. 0.93. What is the ratio of the Value added (current Local Currency Unit) in Kazakhstan in 2008 to that in 2011?
Your response must be concise. 0.61. What is the ratio of the Value added (current Local Currency Unit) in Mozambique in 2008 to that in 2011?
Offer a terse response. 0.75. What is the ratio of the Value added (current Local Currency Unit) of Netherlands in 2008 to that in 2011?
Your answer should be very brief. 1.04. What is the ratio of the Value added (current Local Currency Unit) in Kazakhstan in 2009 to that in 2010?
Provide a short and direct response. 1.06. What is the ratio of the Value added (current Local Currency Unit) of Mozambique in 2009 to that in 2010?
Your answer should be compact. 0.89. What is the ratio of the Value added (current Local Currency Unit) in Netherlands in 2009 to that in 2010?
Offer a terse response. 0.85. What is the ratio of the Value added (current Local Currency Unit) in Kazakhstan in 2009 to that in 2011?
Your answer should be very brief. 0.74. What is the ratio of the Value added (current Local Currency Unit) in Mozambique in 2009 to that in 2011?
Offer a terse response. 0.83. What is the ratio of the Value added (current Local Currency Unit) in Netherlands in 2009 to that in 2011?
Offer a terse response. 0.95. What is the ratio of the Value added (current Local Currency Unit) of Kazakhstan in 2010 to that in 2011?
Make the answer very short. 0.7. What is the ratio of the Value added (current Local Currency Unit) in Mozambique in 2010 to that in 2011?
Your answer should be very brief. 0.94. What is the ratio of the Value added (current Local Currency Unit) of Netherlands in 2010 to that in 2011?
Your answer should be compact. 1.12. What is the difference between the highest and the second highest Value added (current Local Currency Unit) in Kazakhstan?
Your answer should be compact. 3.64e+11. What is the difference between the highest and the second highest Value added (current Local Currency Unit) of Mozambique?
Your answer should be very brief. 6.08e+09. What is the difference between the highest and the second highest Value added (current Local Currency Unit) in Netherlands?
Provide a short and direct response. 7.40e+07. What is the difference between the highest and the lowest Value added (current Local Currency Unit) of Kazakhstan?
Your answer should be very brief. 9.91e+11. What is the difference between the highest and the lowest Value added (current Local Currency Unit) of Mozambique?
Your response must be concise. 6.44e+1. What is the difference between the highest and the lowest Value added (current Local Currency Unit) in Netherlands?
Ensure brevity in your answer.  1.71e+09. 